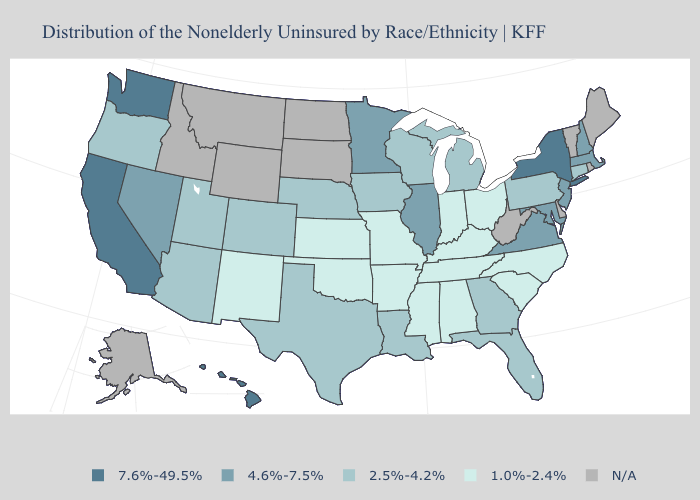Which states have the lowest value in the USA?
Answer briefly. Alabama, Arkansas, Indiana, Kansas, Kentucky, Mississippi, Missouri, New Mexico, North Carolina, Ohio, Oklahoma, South Carolina, Tennessee. Name the states that have a value in the range 7.6%-49.5%?
Keep it brief. California, Hawaii, New York, Washington. Does New York have the lowest value in the USA?
Short answer required. No. Which states hav the highest value in the West?
Be succinct. California, Hawaii, Washington. Does Hawaii have the highest value in the USA?
Give a very brief answer. Yes. What is the highest value in states that border Minnesota?
Concise answer only. 2.5%-4.2%. Which states have the lowest value in the USA?
Quick response, please. Alabama, Arkansas, Indiana, Kansas, Kentucky, Mississippi, Missouri, New Mexico, North Carolina, Ohio, Oklahoma, South Carolina, Tennessee. Which states have the lowest value in the USA?
Quick response, please. Alabama, Arkansas, Indiana, Kansas, Kentucky, Mississippi, Missouri, New Mexico, North Carolina, Ohio, Oklahoma, South Carolina, Tennessee. What is the highest value in the USA?
Answer briefly. 7.6%-49.5%. What is the value of Montana?
Quick response, please. N/A. How many symbols are there in the legend?
Write a very short answer. 5. Name the states that have a value in the range 4.6%-7.5%?
Concise answer only. Illinois, Maryland, Massachusetts, Minnesota, Nevada, New Hampshire, New Jersey, Virginia. Name the states that have a value in the range 2.5%-4.2%?
Short answer required. Arizona, Colorado, Connecticut, Florida, Georgia, Iowa, Louisiana, Michigan, Nebraska, Oregon, Pennsylvania, Texas, Utah, Wisconsin. What is the highest value in the South ?
Write a very short answer. 4.6%-7.5%. 